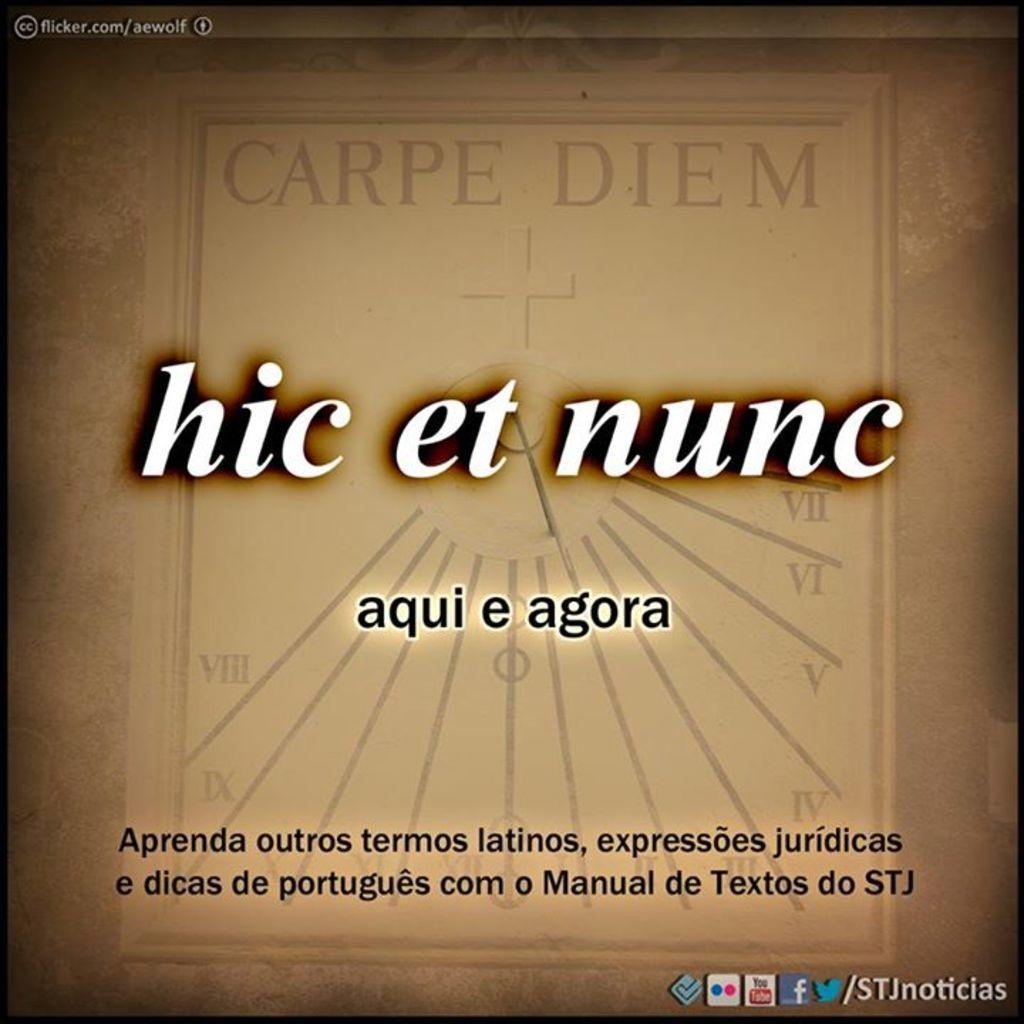<image>
Describe the image concisely. brown background with a clock design  with hic et nunc in the middle that can be seen on youtube, facebook, and twitter 